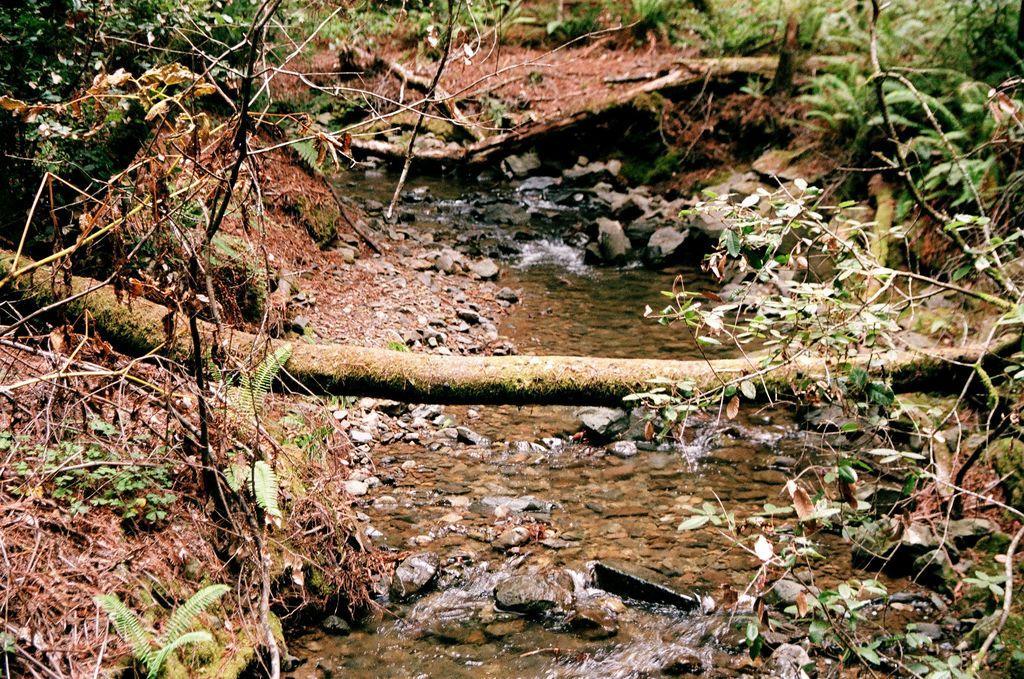Describe this image in one or two sentences. In this image we can see water, rocks, tree trunk, plants and other objects. On the left and right side of the image there are plants and other objects. At the top of the image there is a tree trunk, plants and ground. 